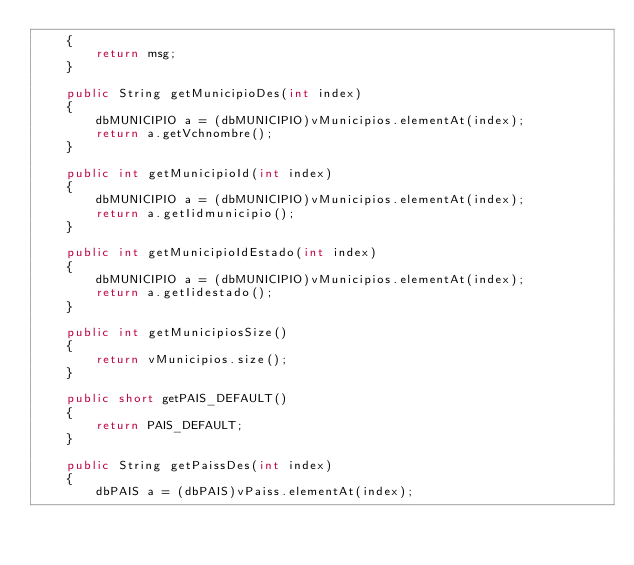Convert code to text. <code><loc_0><loc_0><loc_500><loc_500><_Java_>    {
        return msg;
    }

    public String getMunicipioDes(int index)
    {
        dbMUNICIPIO a = (dbMUNICIPIO)vMunicipios.elementAt(index);
        return a.getVchnombre();
    }

    public int getMunicipioId(int index)
    {
        dbMUNICIPIO a = (dbMUNICIPIO)vMunicipios.elementAt(index);
        return a.getIidmunicipio();
    }

    public int getMunicipioIdEstado(int index)
    {
        dbMUNICIPIO a = (dbMUNICIPIO)vMunicipios.elementAt(index);
        return a.getIidestado();
    }

    public int getMunicipiosSize()
    {
        return vMunicipios.size();
    }

    public short getPAIS_DEFAULT()
    {
        return PAIS_DEFAULT;
    }

    public String getPaissDes(int index)
    {
        dbPAIS a = (dbPAIS)vPaiss.elementAt(index);</code> 